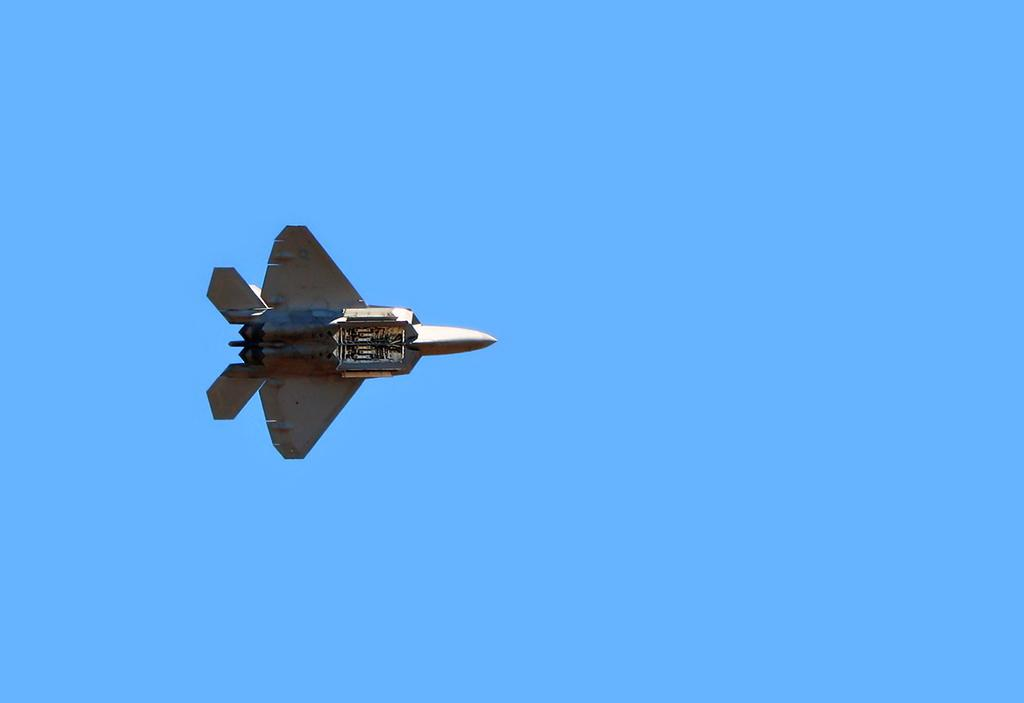What is the main subject of the image? The main subject of the image is an airplane. Where is the airplane located in the image? The airplane is in the center of the image. What can be seen in the background of the image? The sky is visible in the background of the image. What type of nerve can be seen in the image? There is no nerve present in the image; it features an airplane and the sky. How does the fork interact with the airplane in the image? There is no fork present in the image, so it cannot interact with the airplane. 